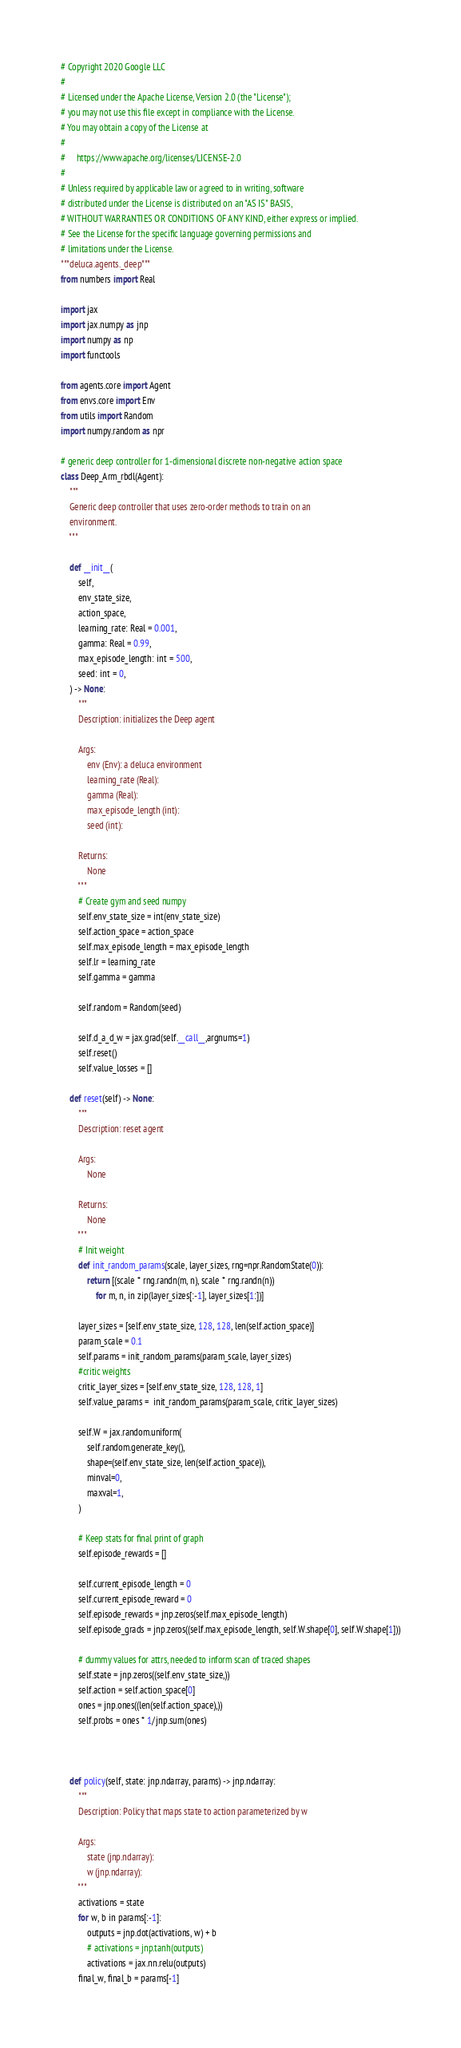Convert code to text. <code><loc_0><loc_0><loc_500><loc_500><_Python_># Copyright 2020 Google LLC
#
# Licensed under the Apache License, Version 2.0 (the "License");
# you may not use this file except in compliance with the License.
# You may obtain a copy of the License at
#
#     https://www.apache.org/licenses/LICENSE-2.0
#
# Unless required by applicable law or agreed to in writing, software
# distributed under the License is distributed on an "AS IS" BASIS,
# WITHOUT WARRANTIES OR CONDITIONS OF ANY KIND, either express or implied.
# See the License for the specific language governing permissions and
# limitations under the License.
"""deluca.agents._deep"""
from numbers import Real

import jax
import jax.numpy as jnp
import numpy as np
import functools

from agents.core import Agent
from envs.core import Env
from utils import Random
import numpy.random as npr

# generic deep controller for 1-dimensional discrete non-negative action space
class Deep_Arm_rbdl(Agent):
    """
    Generic deep controller that uses zero-order methods to train on an
    environment.
    """

    def __init__(
        self,
        env_state_size,
        action_space,
        learning_rate: Real = 0.001,
        gamma: Real = 0.99,
        max_episode_length: int = 500,
        seed: int = 0,
    ) -> None:
        """
        Description: initializes the Deep agent

        Args:
            env (Env): a deluca environment
            learning_rate (Real):
            gamma (Real):
            max_episode_length (int):
            seed (int):

        Returns:
            None
        """
        # Create gym and seed numpy
        self.env_state_size = int(env_state_size)
        self.action_space = action_space
        self.max_episode_length = max_episode_length
        self.lr = learning_rate
        self.gamma = gamma

        self.random = Random(seed)

        self.d_a_d_w = jax.grad(self.__call__,argnums=1)
        self.reset()
        self.value_losses = []

    def reset(self) -> None:
        """
        Description: reset agent

        Args:
            None

        Returns:
            None
        """
        # Init weight
        def init_random_params(scale, layer_sizes, rng=npr.RandomState(0)):
            return [(scale * rng.randn(m, n), scale * rng.randn(n))
                for m, n, in zip(layer_sizes[:-1], layer_sizes[1:])]

        layer_sizes = [self.env_state_size, 128, 128, len(self.action_space)]
        param_scale = 0.1
        self.params = init_random_params(param_scale, layer_sizes)
        #critic weights
        critic_layer_sizes = [self.env_state_size, 128, 128, 1]
        self.value_params =  init_random_params(param_scale, critic_layer_sizes)

        self.W = jax.random.uniform(
            self.random.generate_key(),
            shape=(self.env_state_size, len(self.action_space)),
            minval=0,
            maxval=1,
        )

        # Keep stats for final print of graph
        self.episode_rewards = []

        self.current_episode_length = 0
        self.current_episode_reward = 0
        self.episode_rewards = jnp.zeros(self.max_episode_length)
        self.episode_grads = jnp.zeros((self.max_episode_length, self.W.shape[0], self.W.shape[1]))
        
        # dummy values for attrs, needed to inform scan of traced shapes
        self.state = jnp.zeros((self.env_state_size,))
        self.action = self.action_space[0]
        ones = jnp.ones((len(self.action_space),))
        self.probs = ones * 1/jnp.sum(ones)



    def policy(self, state: jnp.ndarray, params) -> jnp.ndarray:
        """
        Description: Policy that maps state to action parameterized by w

        Args:
            state (jnp.ndarray):
            w (jnp.ndarray):
        """
        activations = state
        for w, b in params[:-1]:
            outputs = jnp.dot(activations, w) + b
            # activations = jnp.tanh(outputs)
            activations = jax.nn.relu(outputs)
        final_w, final_b = params[-1]</code> 